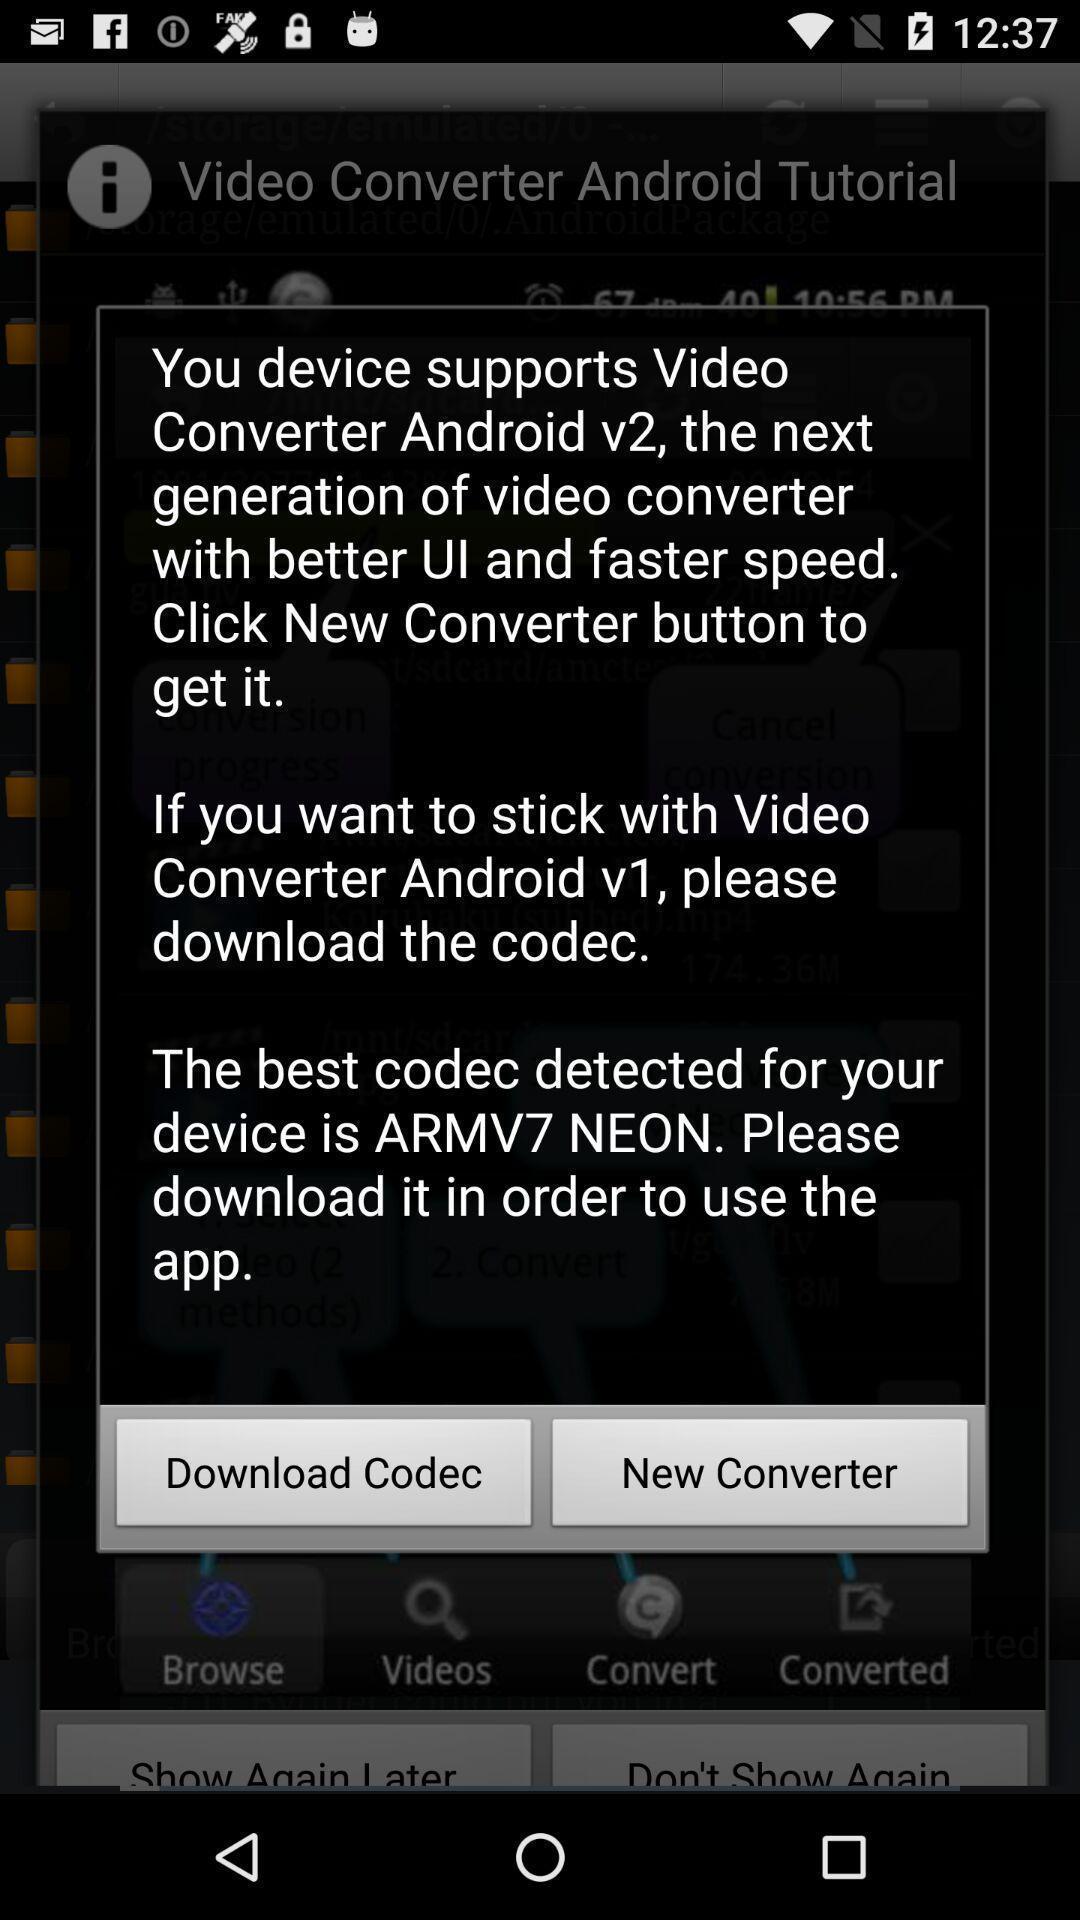Tell me what you see in this picture. Pop-up displaying information about the app. 